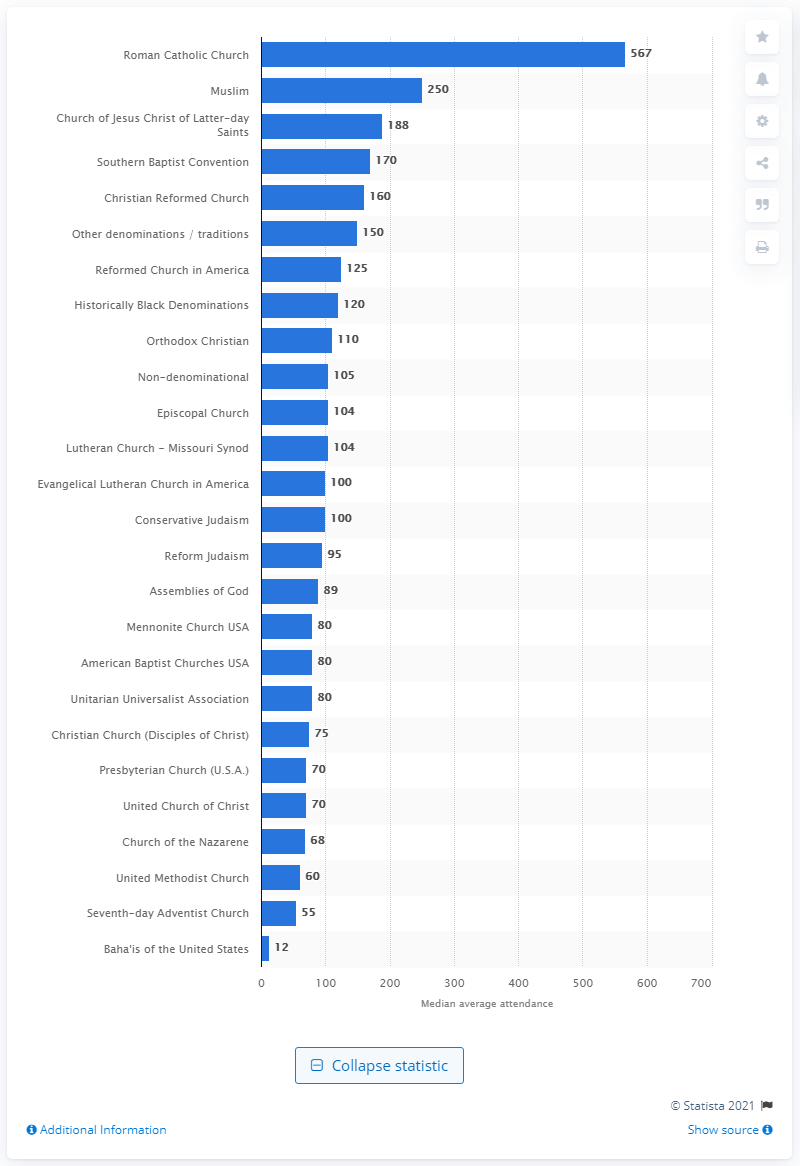Give some essential details in this illustration. The median attendance of American Baptist Churches in 2010 was 80. 